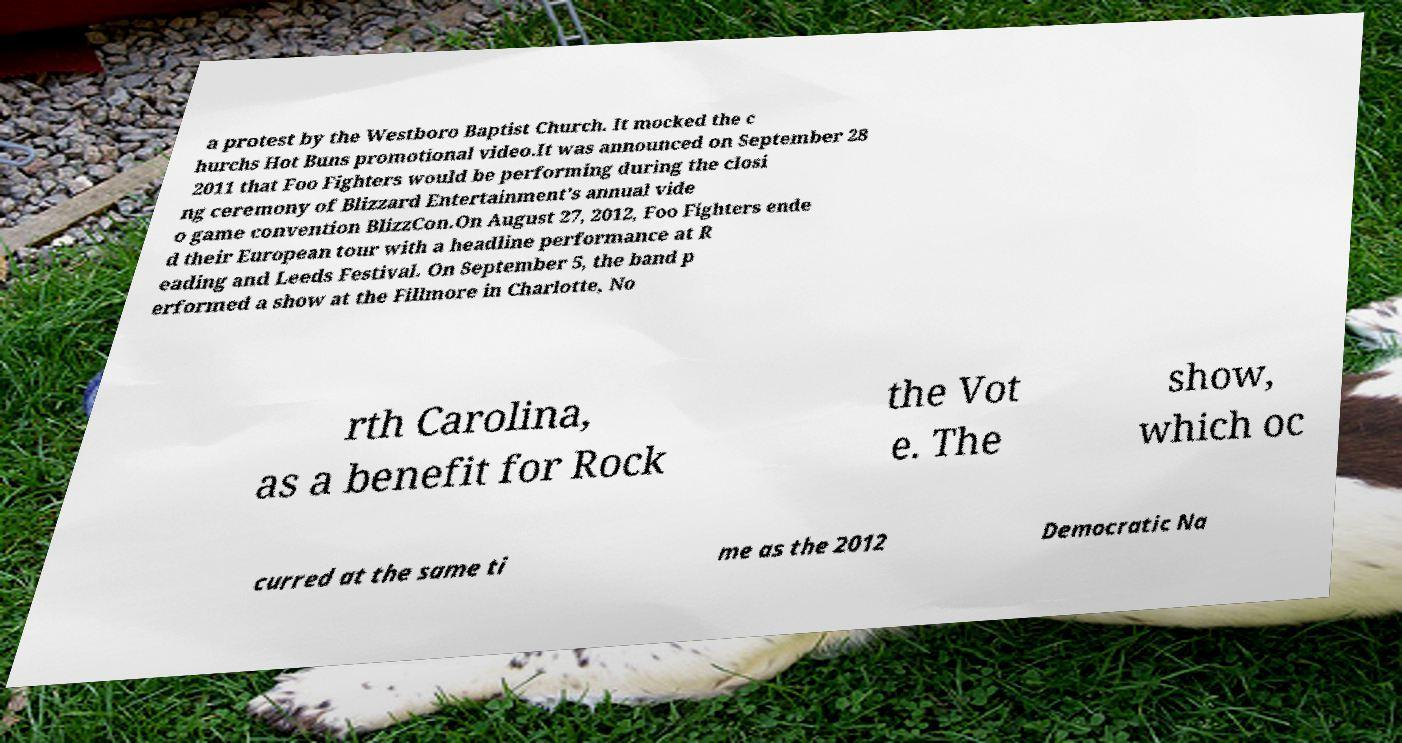Could you extract and type out the text from this image? a protest by the Westboro Baptist Church. It mocked the c hurchs Hot Buns promotional video.It was announced on September 28 2011 that Foo Fighters would be performing during the closi ng ceremony of Blizzard Entertainment's annual vide o game convention BlizzCon.On August 27, 2012, Foo Fighters ende d their European tour with a headline performance at R eading and Leeds Festival. On September 5, the band p erformed a show at the Fillmore in Charlotte, No rth Carolina, as a benefit for Rock the Vot e. The show, which oc curred at the same ti me as the 2012 Democratic Na 